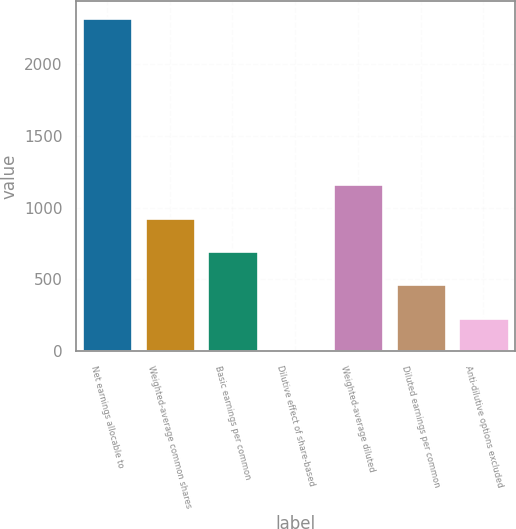Convert chart. <chart><loc_0><loc_0><loc_500><loc_500><bar_chart><fcel>Net earnings allocable to<fcel>Weighted-average common shares<fcel>Basic earnings per common<fcel>Dilutive effect of share-based<fcel>Weighted-average diluted<fcel>Diluted earnings per common<fcel>Anti-dilutive options excluded<nl><fcel>2320<fcel>929.8<fcel>698.1<fcel>3<fcel>1161.5<fcel>466.4<fcel>234.7<nl></chart> 